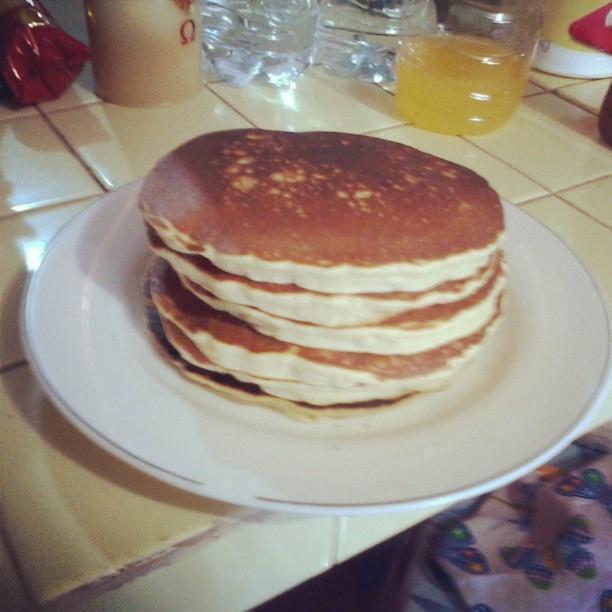How many pancakes are on the plate?
Give a very brief answer. 6. How many cups can be seen?
Give a very brief answer. 1. How many bottles are in the picture?
Give a very brief answer. 3. 